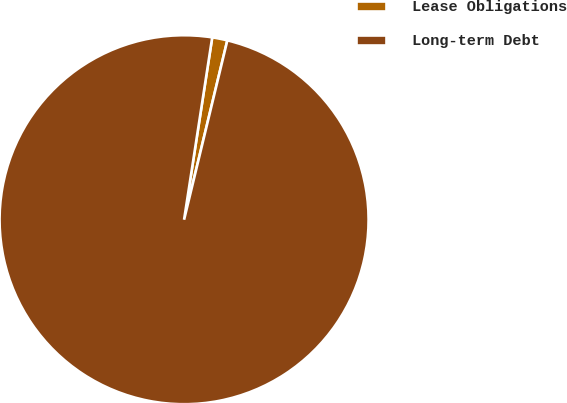<chart> <loc_0><loc_0><loc_500><loc_500><pie_chart><fcel>Lease Obligations<fcel>Long-term Debt<nl><fcel>1.33%<fcel>98.67%<nl></chart> 